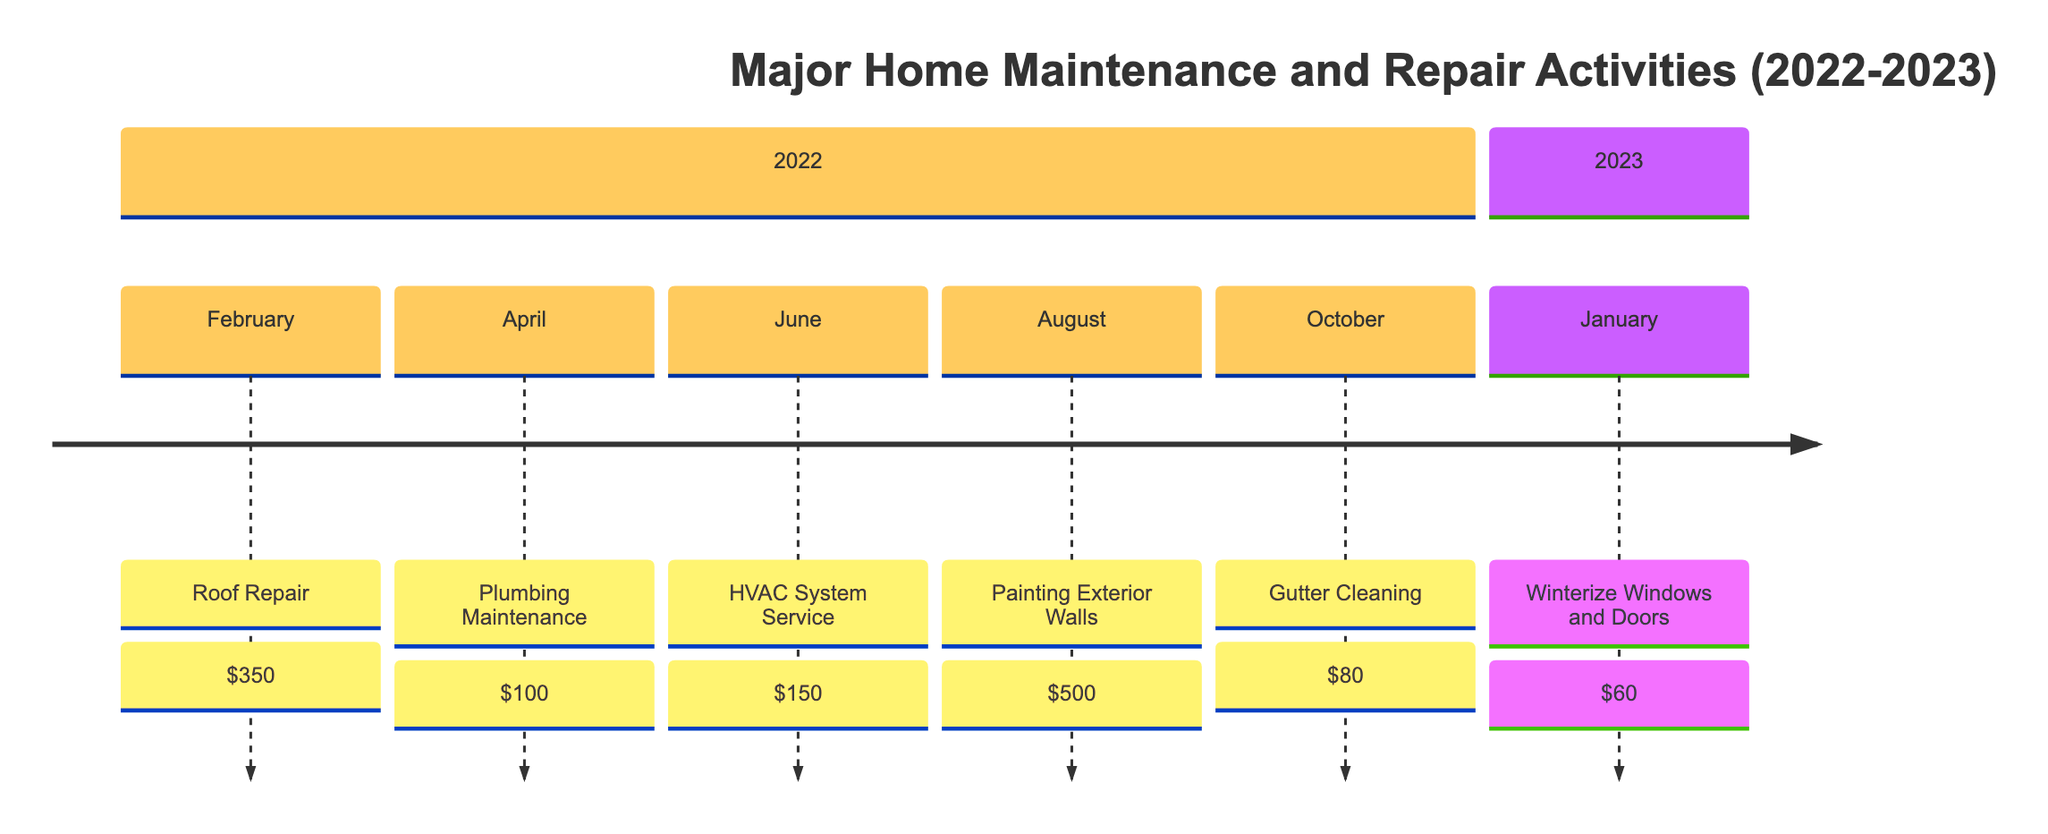What activity took place in February 2022? The timeline shows that in February 2022, the recorded activity was "Roof Repair."
Answer: Roof Repair How much did the Painting Exterior Walls cost? According to the timeline, the cost listed for "Painting Exterior Walls" is $500.
Answer: $500 In which month was Gutter Cleaning performed? The timeline indicates that Gutter Cleaning was performed in October 2022.
Answer: October What is the total cost of all activities in 2022? Adding the costs of all activities in 2022: $350 (Roof Repair) + $100 (Plumbing Maintenance) + $150 (HVAC System Service) + $500 (Painting Exterior Walls) + $80 (Gutter Cleaning) equals a total of $1180.
Answer: $1180 Which activity was the least expensive? The timeline shows that the least expensive activity was "Winterize Windows and Doors" costing $60, in January 2023.
Answer: Winterize Windows and Doors How many repair activities were performed in the year 2022? By counting the activities listed for 2022, there are five repair activities: Roof Repair, Plumbing Maintenance, HVAC System Service, Painting Exterior Walls, and Gutter Cleaning.
Answer: 5 What maintenance was done just before Winterize Windows and Doors? The last activity before "Winterize Windows and Doors" (January 2023) is "Gutter Cleaning," which occurred in October 2022.
Answer: Gutter Cleaning What was the purpose of the HVAC System Service? The purpose stated for the "HVAC System Service" is routine maintenance of the heating and cooling system.
Answer: Routine maintenance Which month had two maintenance activities recorded? The timeline shows that in August 2022, there was one activity recorded: Painting Exterior Walls, indicating there were no overlapping activities in that month, confirming no month had two activities.
Answer: None 